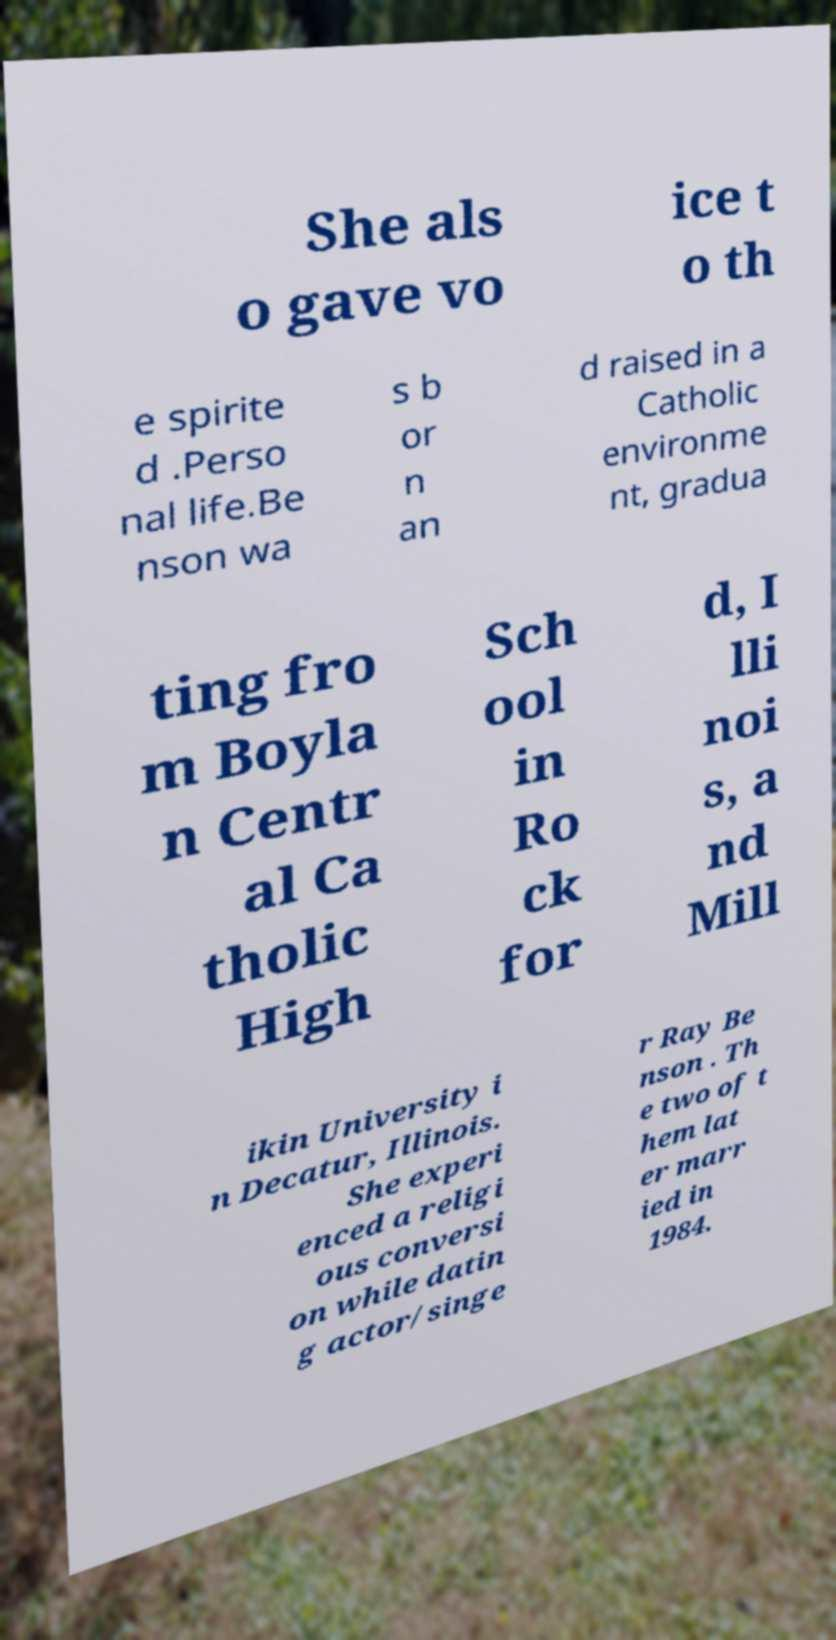Could you extract and type out the text from this image? She als o gave vo ice t o th e spirite d .Perso nal life.Be nson wa s b or n an d raised in a Catholic environme nt, gradua ting fro m Boyla n Centr al Ca tholic High Sch ool in Ro ck for d, I lli noi s, a nd Mill ikin University i n Decatur, Illinois. She experi enced a religi ous conversi on while datin g actor/singe r Ray Be nson . Th e two of t hem lat er marr ied in 1984. 